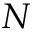<formula> <loc_0><loc_0><loc_500><loc_500>N</formula> 